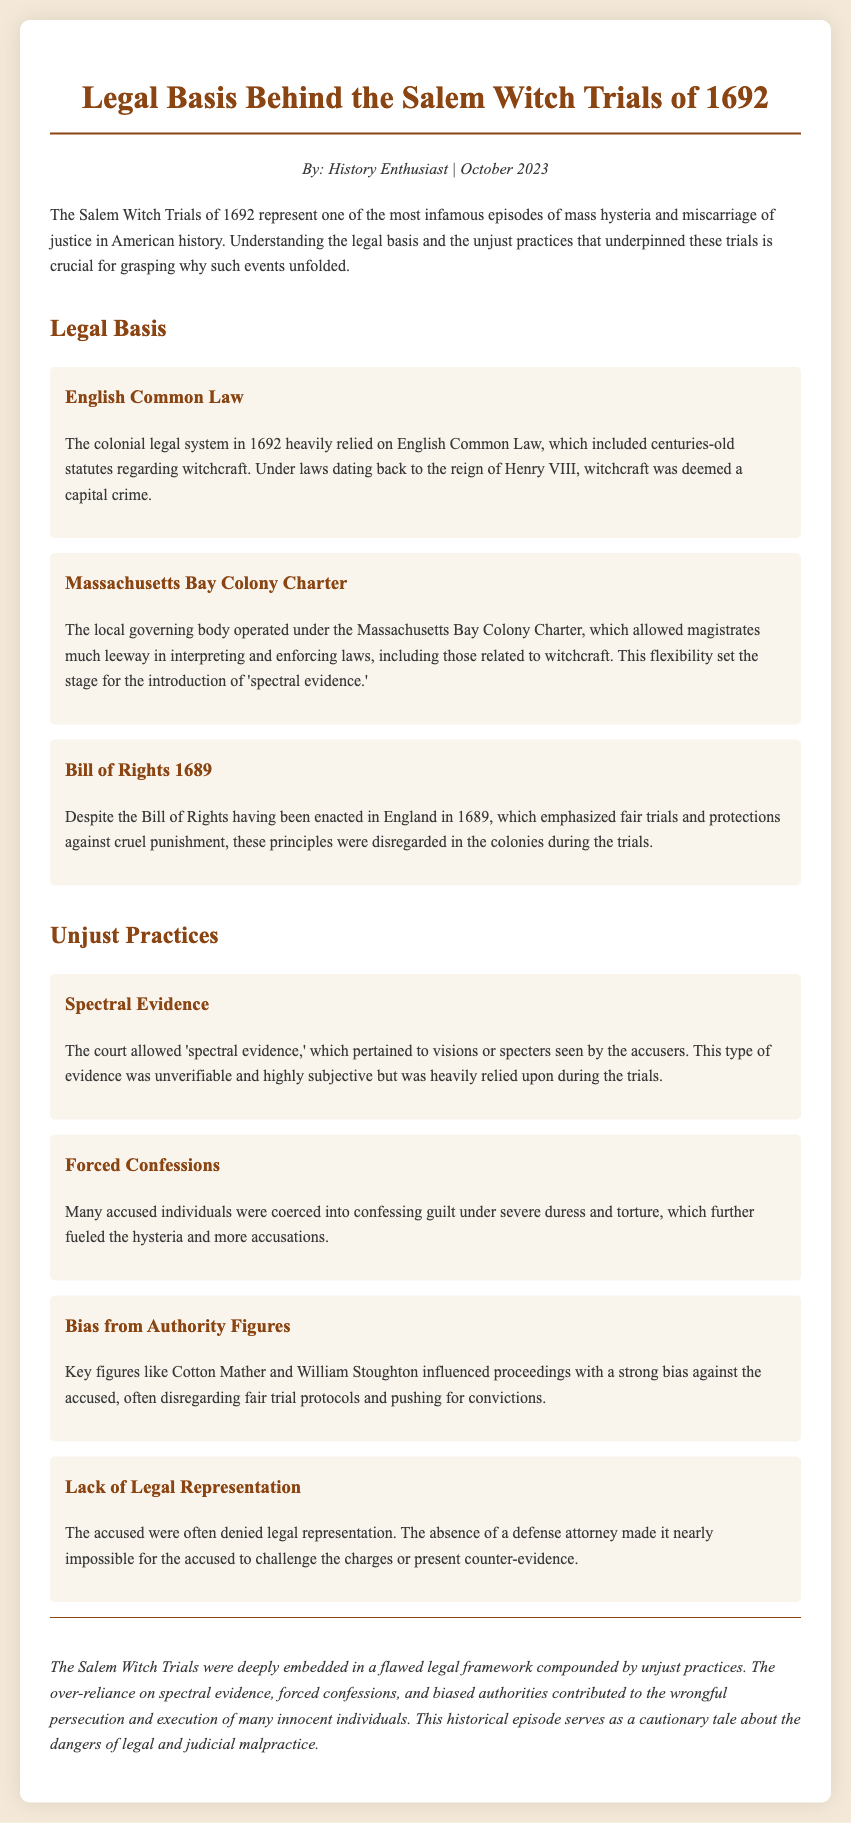What year did the Salem Witch Trials occur? The document specifies that the Salem Witch Trials took place in the year 1692.
Answer: 1692 What legal framework did the colonial system rely on? The document indicates that the colonial legal system in 1692 heavily relied on English Common Law.
Answer: English Common Law What type of evidence was heavily relied upon during the trials? The document mentions that the court allowed 'spectral evidence,' which was a significant aspect of the trials.
Answer: spectral evidence Who were two key figures influencing the trials? The document lists Cotton Mather and William Stoughton as key figures who influenced the proceedings with bias against the accused.
Answer: Cotton Mather and William Stoughton What was often denied to the accused individuals? The document highlights that the accused were often denied legal representation during the trials.
Answer: legal representation Why were many confessions coerced? The document explains that many accused individuals were coerced into confessing guilt under severe duress and torture.
Answer: due to severe duress and torture What does the document suggest about the principles of the Bill of Rights? It states that despite the Bill of Rights emphasizing fair trials, these principles were disregarded in the colonies during the trials.
Answer: disregarded What was the outcome of the legal practices mentioned? The document asserts that the practices led to wrongful persecution and execution of innocent individuals.
Answer: wrongful persecution and execution 